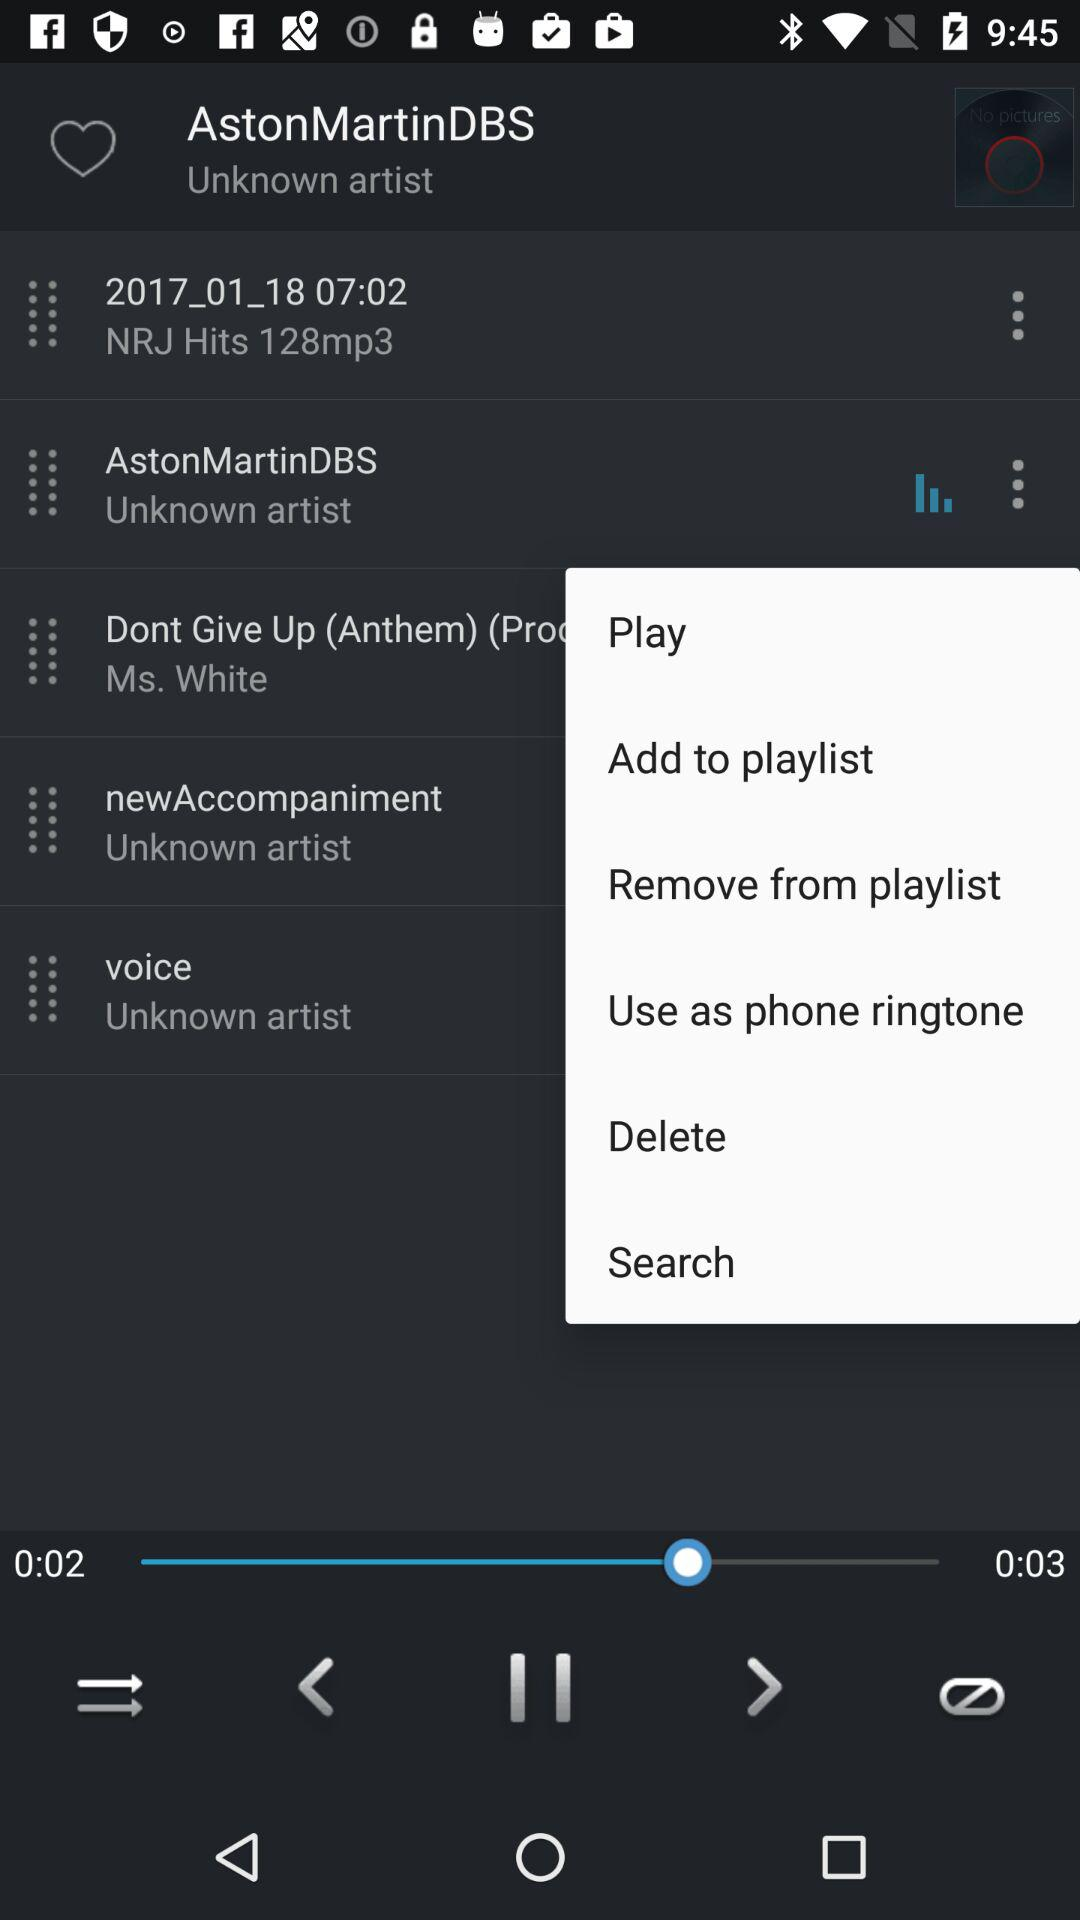How many seconds longer is the current song than the previous one?
Answer the question using a single word or phrase. 1 